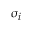<formula> <loc_0><loc_0><loc_500><loc_500>\sigma _ { i }</formula> 